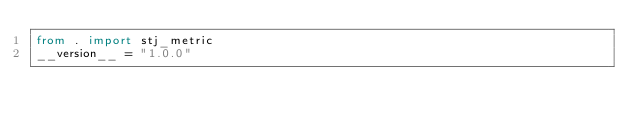Convert code to text. <code><loc_0><loc_0><loc_500><loc_500><_Python_>from . import stj_metric
__version__ = "1.0.0"
</code> 